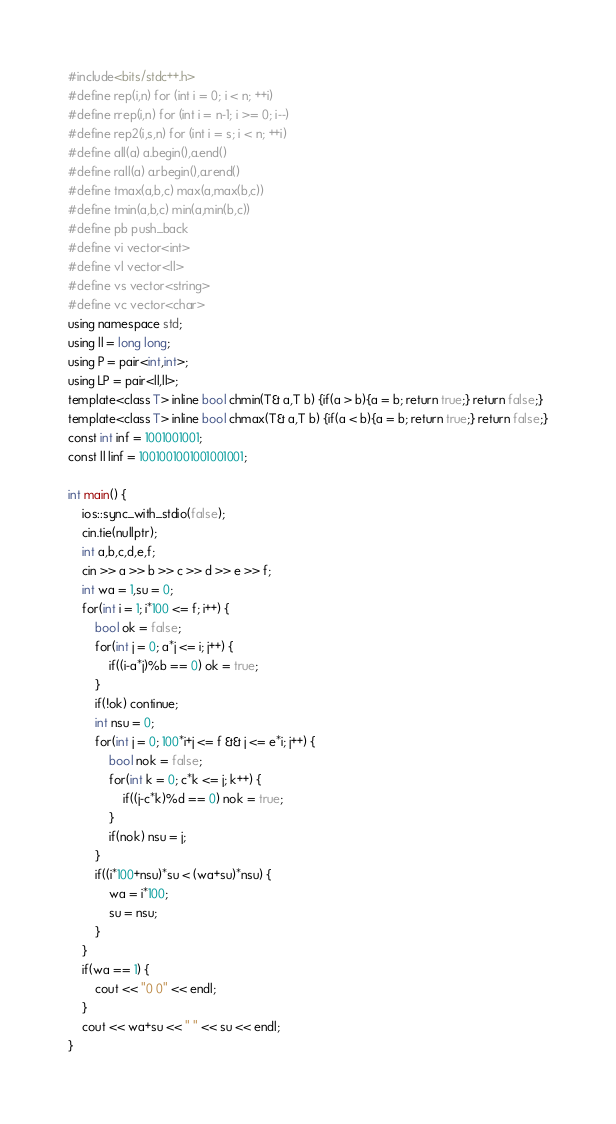<code> <loc_0><loc_0><loc_500><loc_500><_C++_>#include<bits/stdc++.h>
#define rep(i,n) for (int i = 0; i < n; ++i)
#define rrep(i,n) for (int i = n-1; i >= 0; i--)
#define rep2(i,s,n) for (int i = s; i < n; ++i)
#define all(a) a.begin(),a.end()
#define rall(a) a.rbegin(),a.rend()
#define tmax(a,b,c) max(a,max(b,c))
#define tmin(a,b,c) min(a,min(b,c))
#define pb push_back
#define vi vector<int>
#define vl vector<ll>
#define vs vector<string>
#define vc vector<char>
using namespace std;
using ll = long long;
using P = pair<int,int>;
using LP = pair<ll,ll>;
template<class T> inline bool chmin(T& a,T b) {if(a > b){a = b; return true;} return false;}
template<class T> inline bool chmax(T& a,T b) {if(a < b){a = b; return true;} return false;}
const int inf = 1001001001;
const ll linf = 1001001001001001001;

int main() {
    ios::sync_with_stdio(false);
    cin.tie(nullptr);
    int a,b,c,d,e,f;
    cin >> a >> b >> c >> d >> e >> f;
    int wa = 1,su = 0;
    for(int i = 1; i*100 <= f; i++) {
        bool ok = false;
        for(int j = 0; a*j <= i; j++) {
            if((i-a*j)%b == 0) ok = true;
        }
        if(!ok) continue;
        int nsu = 0;
        for(int j = 0; 100*i+j <= f && j <= e*i; j++) {
            bool nok = false;
            for(int k = 0; c*k <= j; k++) {
                if((j-c*k)%d == 0) nok = true;
            }
            if(nok) nsu = j;
        }
        if((i*100+nsu)*su < (wa+su)*nsu) {
            wa = i*100;
            su = nsu;
        }
    }
    if(wa == 1) {
        cout << "0 0" << endl;
    }
    cout << wa+su << " " << su << endl;
}
</code> 